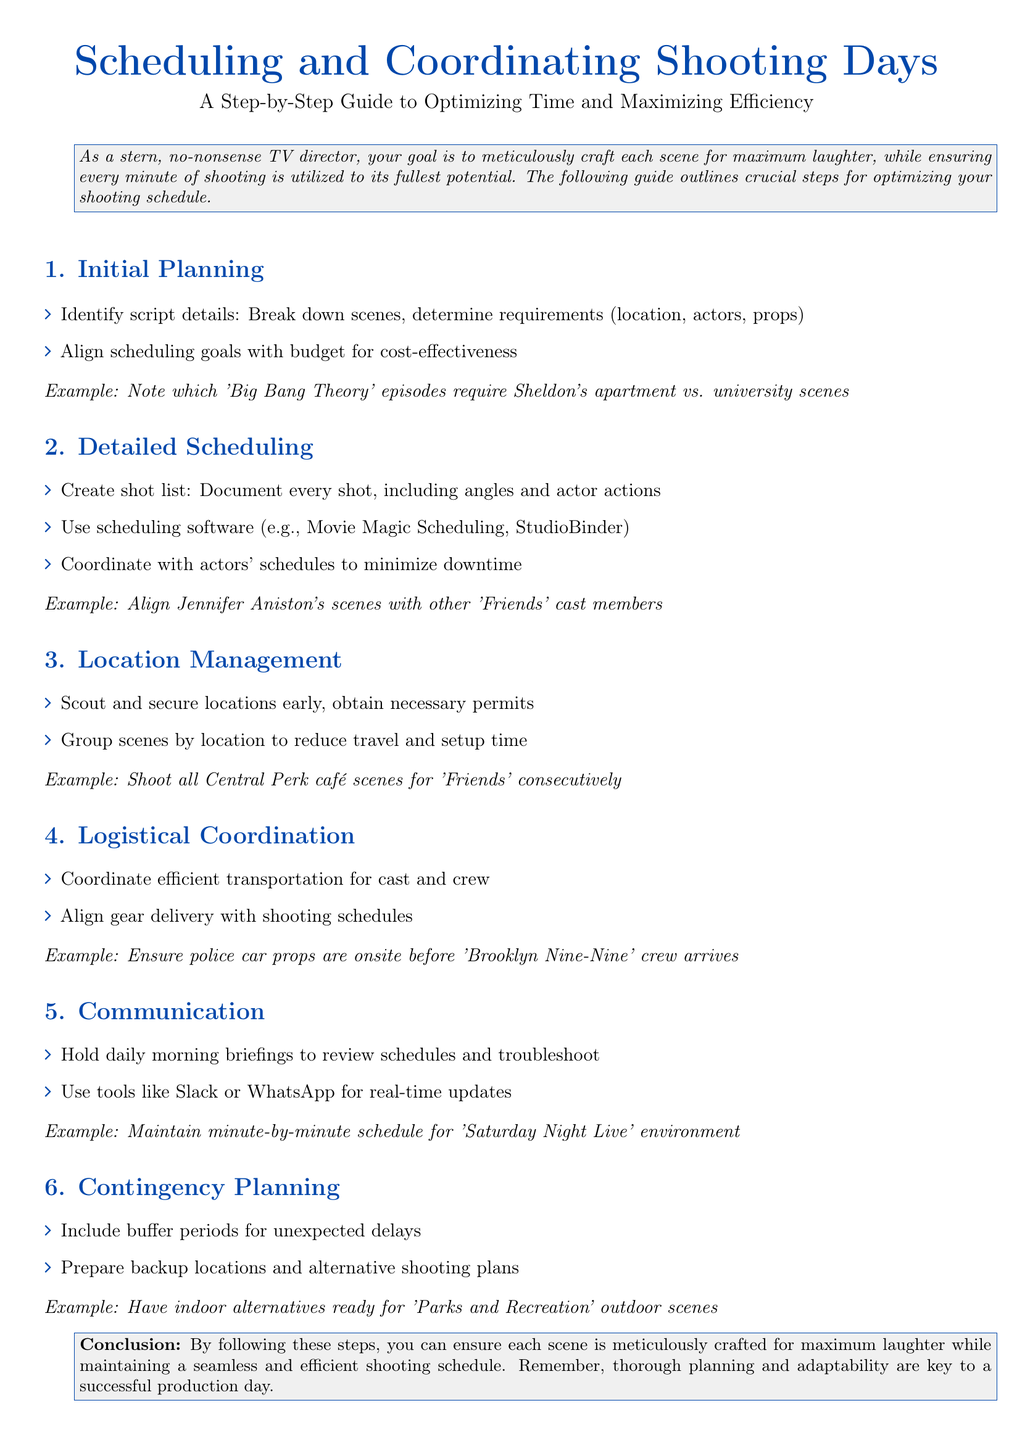What is the title of the guide? The title of the guide is indicated at the beginning of the document.
Answer: Scheduling and Coordinating Shooting Days How many steps are outlined in the guide? The steps are enumerated in the document under different sections.
Answer: Six What is the first step in the guide? The first step is stated in the first section of the document.
Answer: Initial Planning What software is suggested for detailed scheduling? The document mentions specific software tools for scheduling.
Answer: Movie Magic Scheduling, StudioBinder What is a crucial aspect of location management? The document discusses important actions regarding location management.
Answer: Scout and secure locations early What is a recommended tool for communication? The guide suggests specific tools for maintaining communication.
Answer: Slack or WhatsApp What is the focus of the contingency planning step? The document emphasizes what needs to be included in contingency planning.
Answer: Buffer periods for unexpected delays Which show’s scenes should be aligned with other cast members according to the example? The example provided in the detailed scheduling section references a specific show.
Answer: Friends 